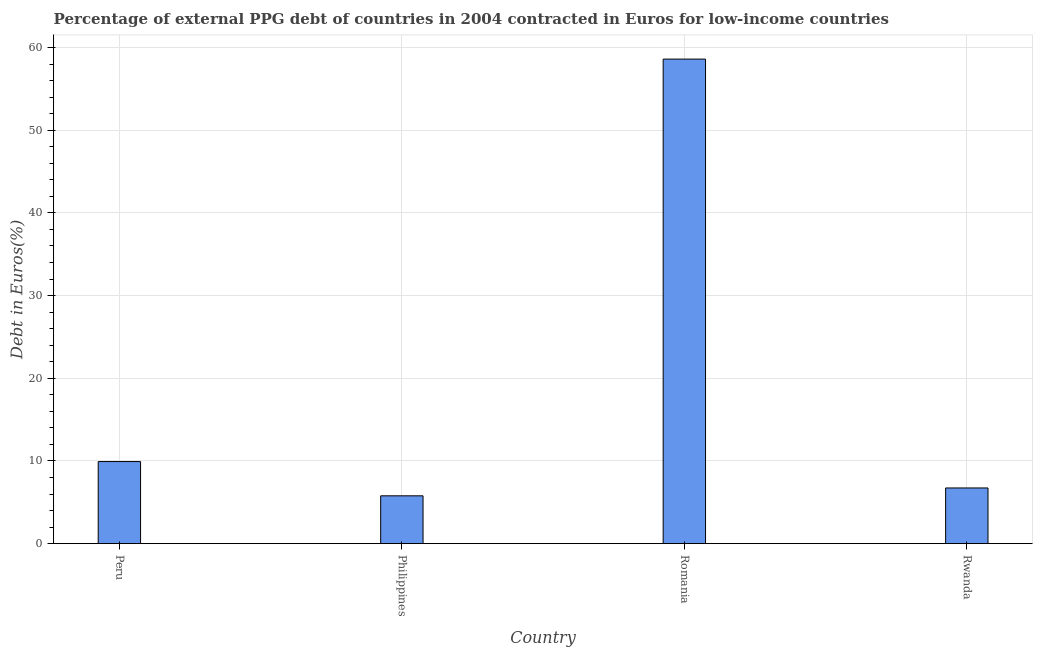Does the graph contain any zero values?
Ensure brevity in your answer.  No. What is the title of the graph?
Your answer should be very brief. Percentage of external PPG debt of countries in 2004 contracted in Euros for low-income countries. What is the label or title of the Y-axis?
Offer a terse response. Debt in Euros(%). What is the currency composition of ppg debt in Rwanda?
Ensure brevity in your answer.  6.74. Across all countries, what is the maximum currency composition of ppg debt?
Your answer should be compact. 58.6. Across all countries, what is the minimum currency composition of ppg debt?
Offer a very short reply. 5.79. In which country was the currency composition of ppg debt maximum?
Make the answer very short. Romania. In which country was the currency composition of ppg debt minimum?
Ensure brevity in your answer.  Philippines. What is the sum of the currency composition of ppg debt?
Offer a very short reply. 81.05. What is the difference between the currency composition of ppg debt in Peru and Rwanda?
Offer a terse response. 3.19. What is the average currency composition of ppg debt per country?
Offer a very short reply. 20.26. What is the median currency composition of ppg debt?
Offer a terse response. 8.33. In how many countries, is the currency composition of ppg debt greater than 56 %?
Offer a very short reply. 1. What is the ratio of the currency composition of ppg debt in Romania to that in Rwanda?
Offer a very short reply. 8.7. Is the currency composition of ppg debt in Philippines less than that in Rwanda?
Provide a short and direct response. Yes. What is the difference between the highest and the second highest currency composition of ppg debt?
Your answer should be very brief. 48.68. Is the sum of the currency composition of ppg debt in Peru and Romania greater than the maximum currency composition of ppg debt across all countries?
Keep it short and to the point. Yes. What is the difference between the highest and the lowest currency composition of ppg debt?
Offer a terse response. 52.82. How many bars are there?
Your answer should be compact. 4. Are all the bars in the graph horizontal?
Offer a terse response. No. How many countries are there in the graph?
Make the answer very short. 4. Are the values on the major ticks of Y-axis written in scientific E-notation?
Make the answer very short. No. What is the Debt in Euros(%) in Peru?
Ensure brevity in your answer.  9.93. What is the Debt in Euros(%) in Philippines?
Give a very brief answer. 5.79. What is the Debt in Euros(%) of Romania?
Give a very brief answer. 58.6. What is the Debt in Euros(%) of Rwanda?
Your answer should be very brief. 6.74. What is the difference between the Debt in Euros(%) in Peru and Philippines?
Offer a very short reply. 4.14. What is the difference between the Debt in Euros(%) in Peru and Romania?
Make the answer very short. -48.68. What is the difference between the Debt in Euros(%) in Peru and Rwanda?
Your answer should be compact. 3.19. What is the difference between the Debt in Euros(%) in Philippines and Romania?
Keep it short and to the point. -52.82. What is the difference between the Debt in Euros(%) in Philippines and Rwanda?
Keep it short and to the point. -0.95. What is the difference between the Debt in Euros(%) in Romania and Rwanda?
Make the answer very short. 51.87. What is the ratio of the Debt in Euros(%) in Peru to that in Philippines?
Ensure brevity in your answer.  1.72. What is the ratio of the Debt in Euros(%) in Peru to that in Romania?
Give a very brief answer. 0.17. What is the ratio of the Debt in Euros(%) in Peru to that in Rwanda?
Ensure brevity in your answer.  1.47. What is the ratio of the Debt in Euros(%) in Philippines to that in Romania?
Provide a succinct answer. 0.1. What is the ratio of the Debt in Euros(%) in Philippines to that in Rwanda?
Give a very brief answer. 0.86. What is the ratio of the Debt in Euros(%) in Romania to that in Rwanda?
Provide a short and direct response. 8.7. 